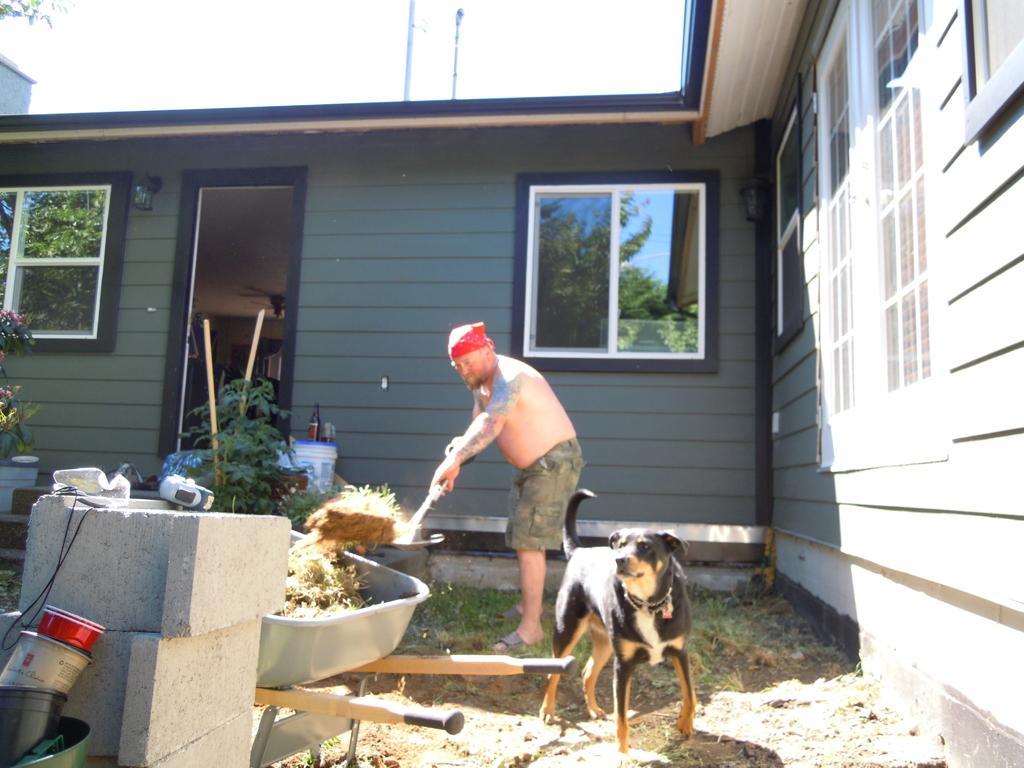In one or two sentences, can you explain what this image depicts? In this image in the front there are stones and there are boxes and there is a trolley and in the trolley there is grass. In the center there is a dog and there is a person standing and pouring water. In the background there is a building, there are plants and there are poles. 